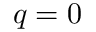Convert formula to latex. <formula><loc_0><loc_0><loc_500><loc_500>q = 0</formula> 